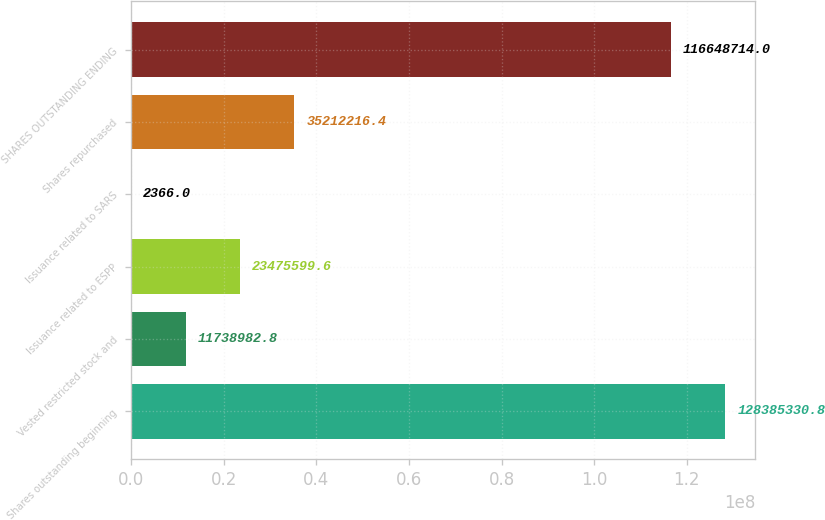Convert chart to OTSL. <chart><loc_0><loc_0><loc_500><loc_500><bar_chart><fcel>Shares outstanding beginning<fcel>Vested restricted stock and<fcel>Issuance related to ESPP<fcel>Issuance related to SARS<fcel>Shares repurchased<fcel>SHARES OUTSTANDING ENDING<nl><fcel>1.28385e+08<fcel>1.1739e+07<fcel>2.34756e+07<fcel>2366<fcel>3.52122e+07<fcel>1.16649e+08<nl></chart> 